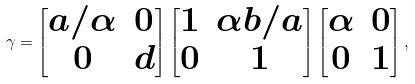Convert formula to latex. <formula><loc_0><loc_0><loc_500><loc_500>\gamma = \begin{bmatrix} a / \alpha & 0 \\ 0 & d \end{bmatrix} \begin{bmatrix} 1 & \alpha b / a \\ 0 & 1 \end{bmatrix} \begin{bmatrix} \alpha & 0 \\ 0 & 1 \end{bmatrix} ,</formula> 